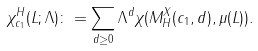Convert formula to latex. <formula><loc_0><loc_0><loc_500><loc_500>\chi _ { c _ { 1 } } ^ { H } ( L ; \Lambda ) & \colon = \sum _ { d \geq 0 } \Lambda ^ { d } \chi ( M ^ { X } _ { H } ( c _ { 1 } , d ) , \mu ( L ) ) .</formula> 